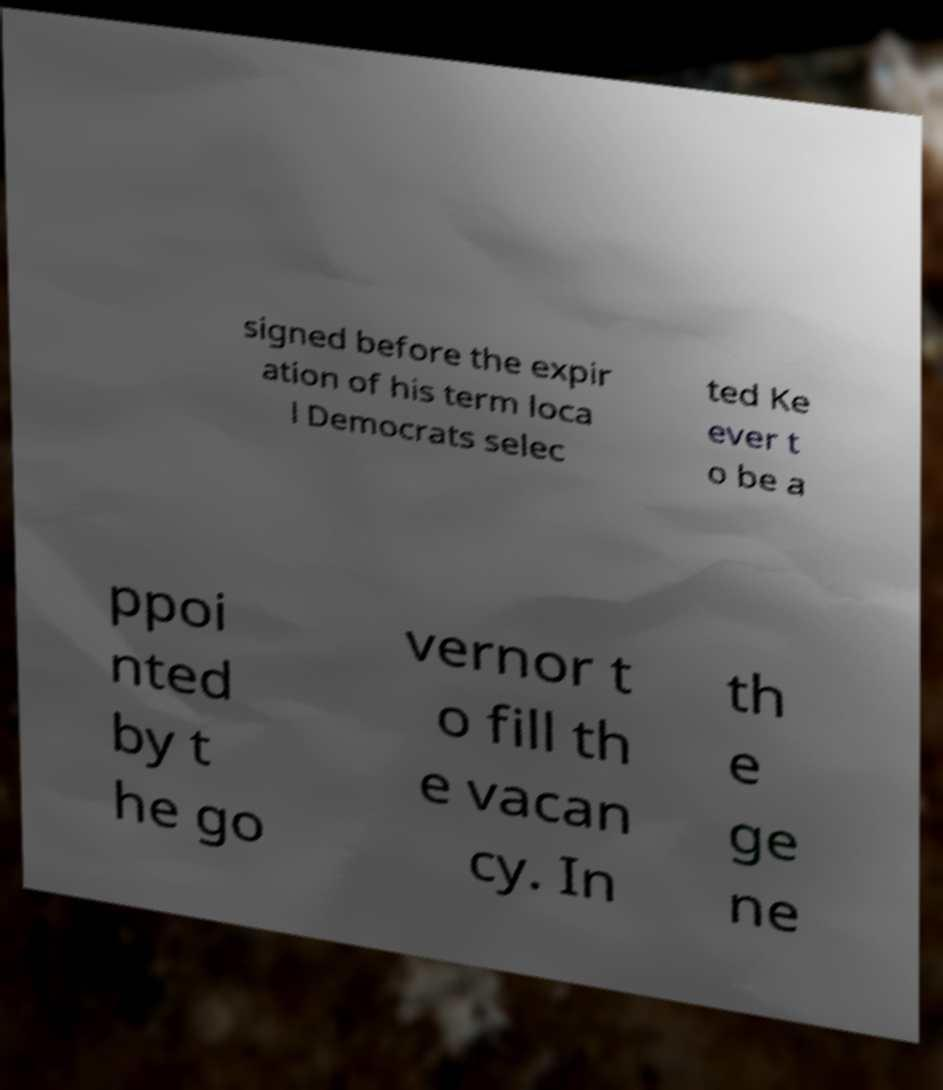Can you accurately transcribe the text from the provided image for me? signed before the expir ation of his term loca l Democrats selec ted Ke ever t o be a ppoi nted by t he go vernor t o fill th e vacan cy. In th e ge ne 